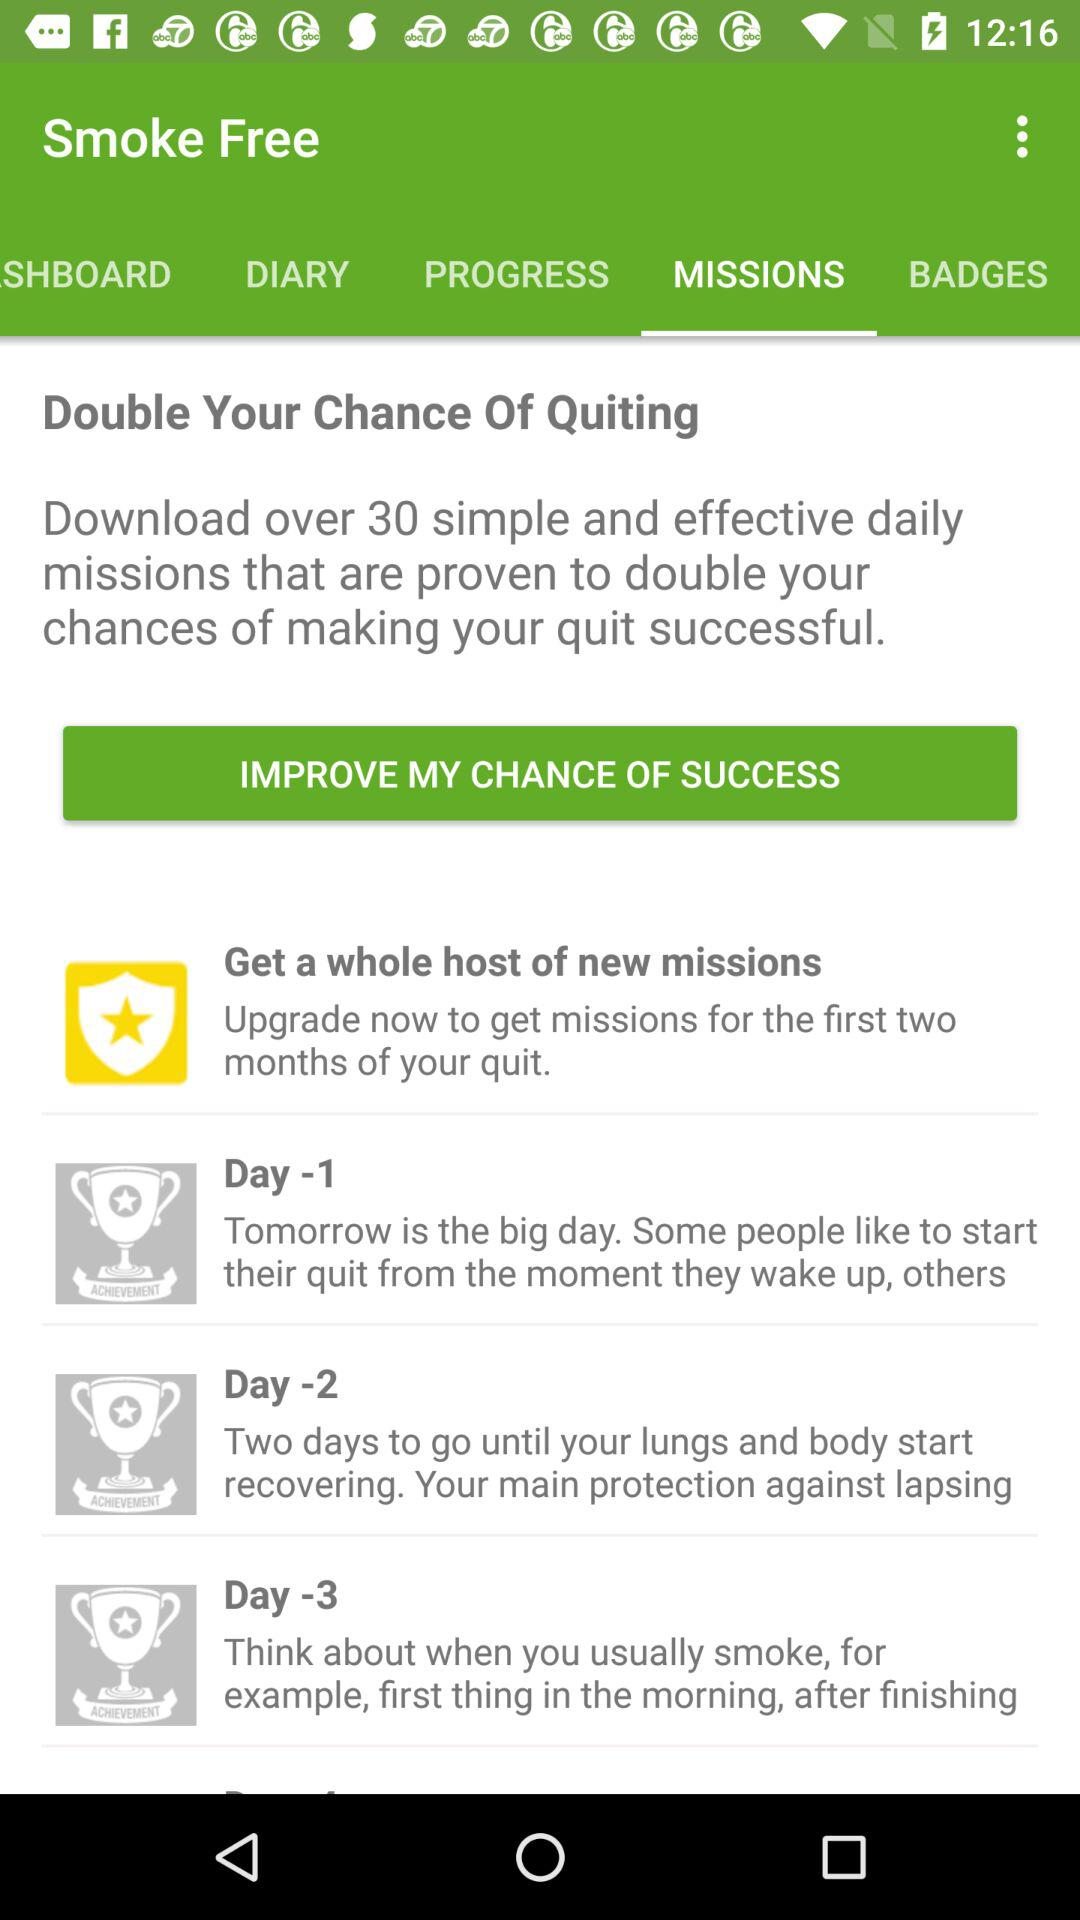How many days before the quit date are there missions for?
Answer the question using a single word or phrase. 3 